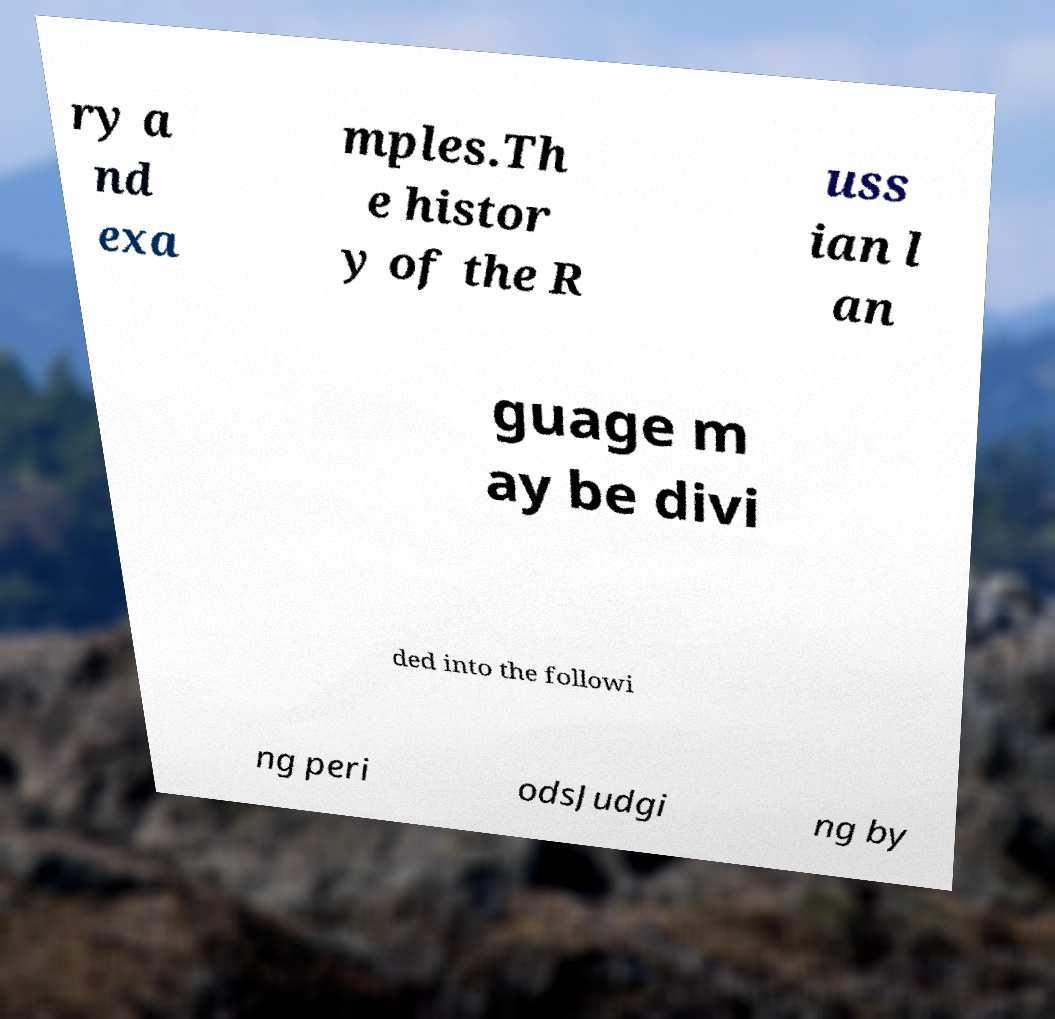Can you accurately transcribe the text from the provided image for me? ry a nd exa mples.Th e histor y of the R uss ian l an guage m ay be divi ded into the followi ng peri odsJudgi ng by 